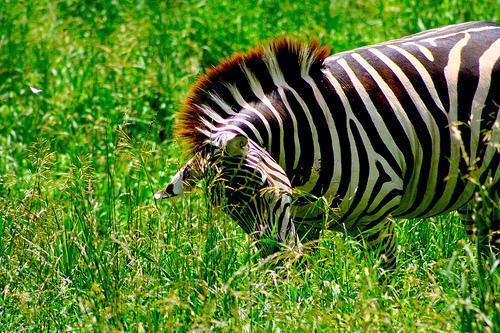How many zebras are there?
Give a very brief answer. 1. 